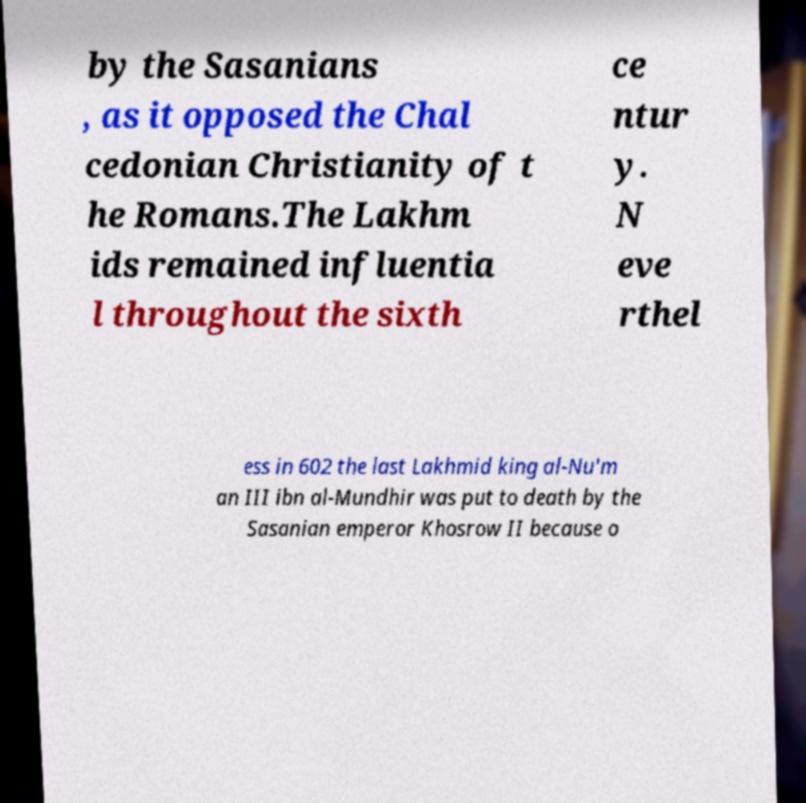Please identify and transcribe the text found in this image. by the Sasanians , as it opposed the Chal cedonian Christianity of t he Romans.The Lakhm ids remained influentia l throughout the sixth ce ntur y. N eve rthel ess in 602 the last Lakhmid king al-Nu'm an III ibn al-Mundhir was put to death by the Sasanian emperor Khosrow II because o 